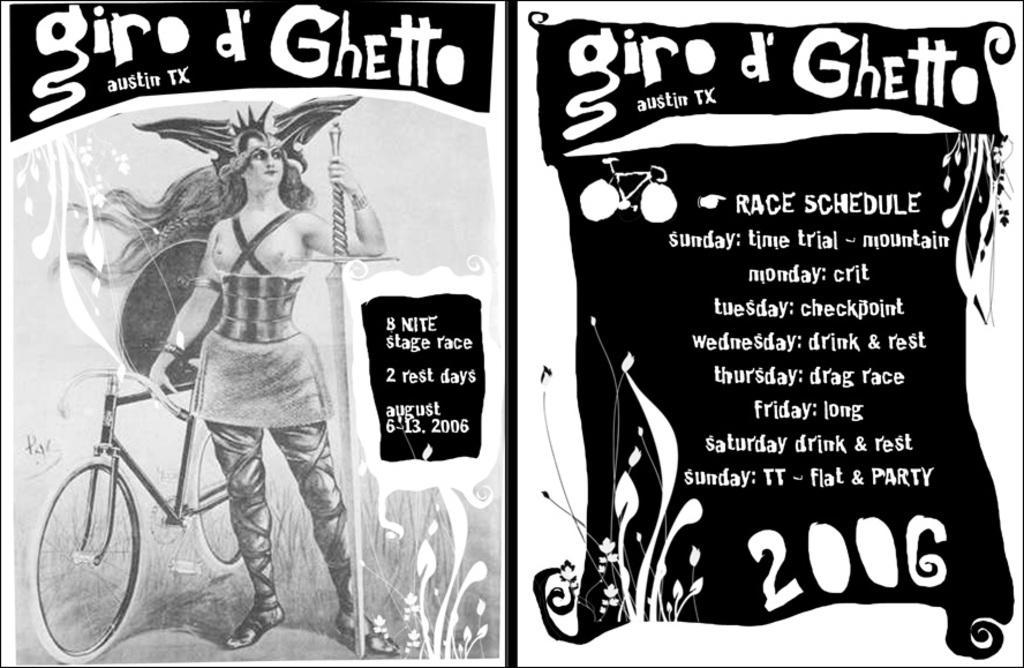Could you give a brief overview of what you see in this image? In this image I can see it looks like posters, on the left side there is a person standing, beside this person there is a cycle. On the right side there is the text. 